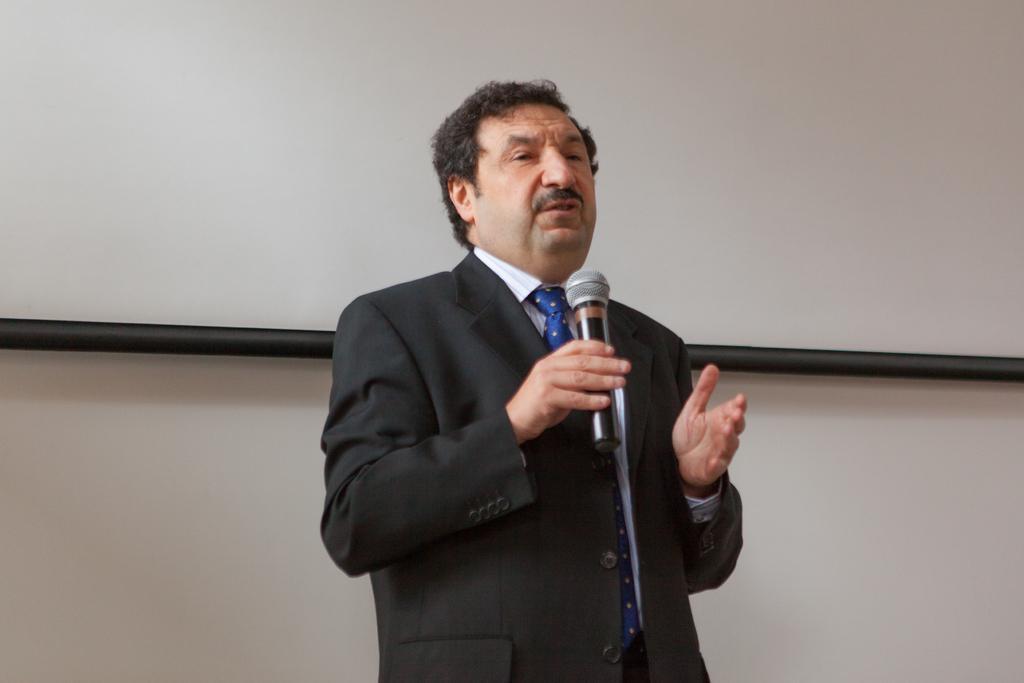In one or two sentences, can you explain what this image depicts? A man is standing and holding a microphone speaking in it. He wear a coat tie. 